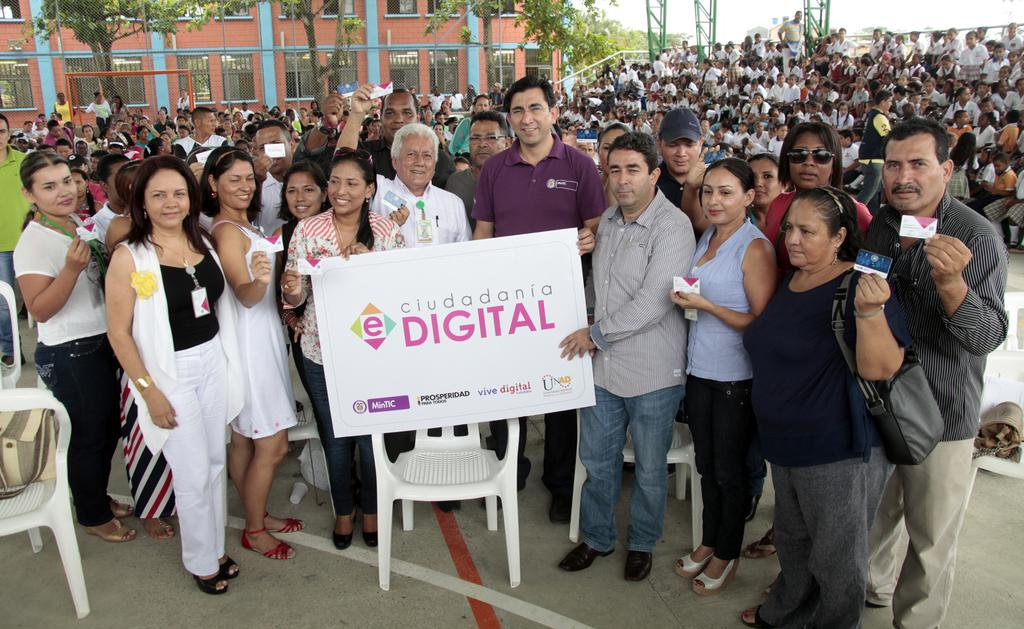What type of furniture is present in the image? There are chairs in the image. What can be seen hanging or displayed in the image? There is a banner in the image. Who or what is present in the image? There is a group of people in the image. What information is mentioned in the image? Current polls are mentioned in the image. What type of natural environment is visible in the image? There are trees in the image. What type of man-made structures are visible in the image? There are buildings in the image. Can you tell me how many crows are perched on the banner in the image? There are no crows present in the image; it only features a banner, chairs, a group of people, current polls, trees, and buildings. What type of advertisement is displayed on the banner in the image? There is no advertisement displayed on the banner in the image; it only mentions current polls. 